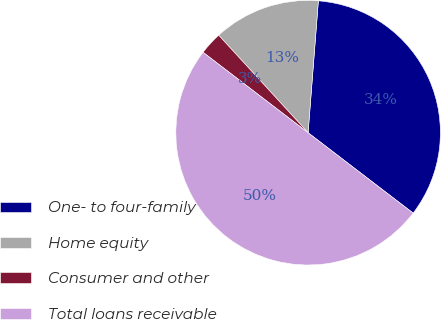Convert chart to OTSL. <chart><loc_0><loc_0><loc_500><loc_500><pie_chart><fcel>One- to four-family<fcel>Home equity<fcel>Consumer and other<fcel>Total loans receivable<nl><fcel>34.16%<fcel>13.05%<fcel>2.79%<fcel>50.0%<nl></chart> 